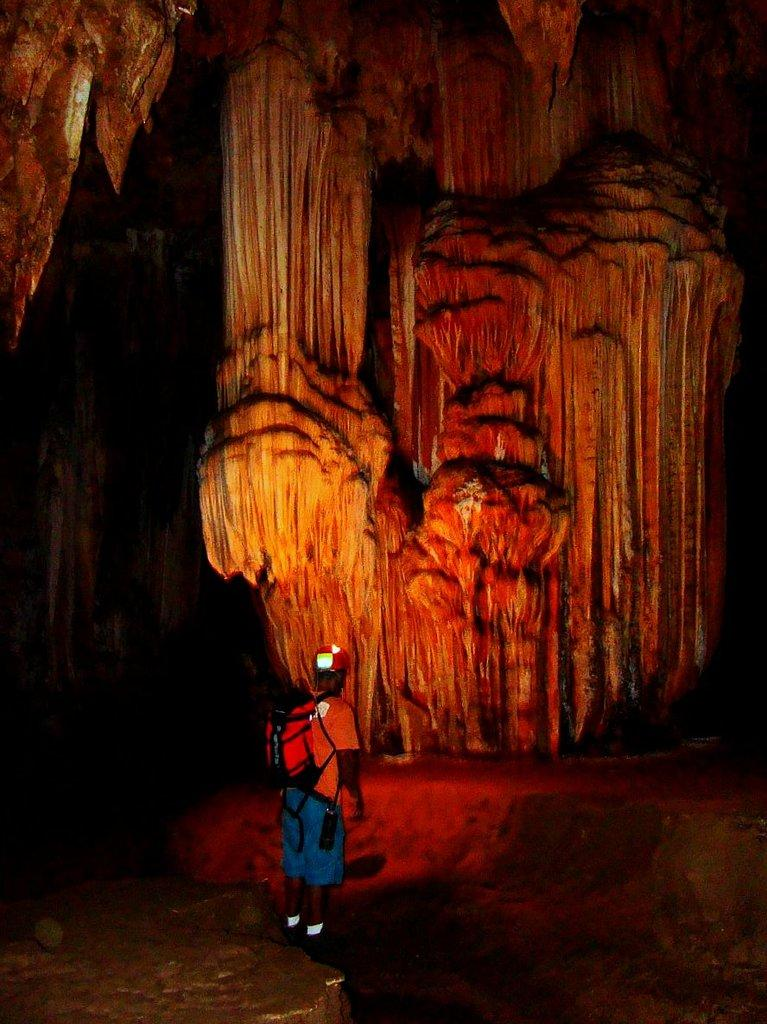Who is present in the image? There is a man in the image. Where is the man located? The man is standing in a cave. What is the man wearing on his upper body? The man is wearing a red t-shirt. What is the man wearing on his back? The man is wearing a red bag. What is in front of the man? There is a rock in front of the man. What type of headwear is the man wearing? The man is wearing a cap. What type of quiver is the man carrying on his back? There is no quiver present in the image; the man is wearing a red bag. How many buckets can be seen in the image? There are no buckets present in the image. 